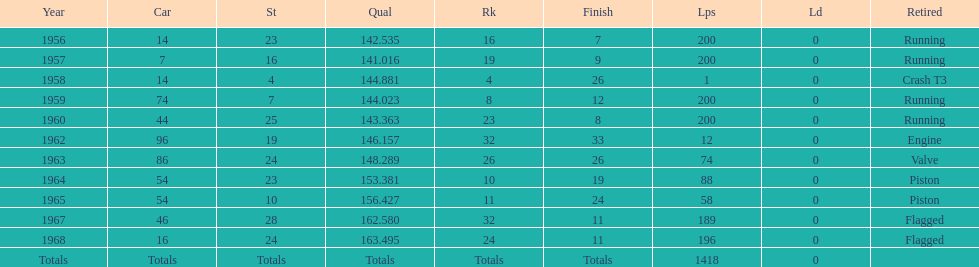What year is associated with the last qual on the chart? 1968. 